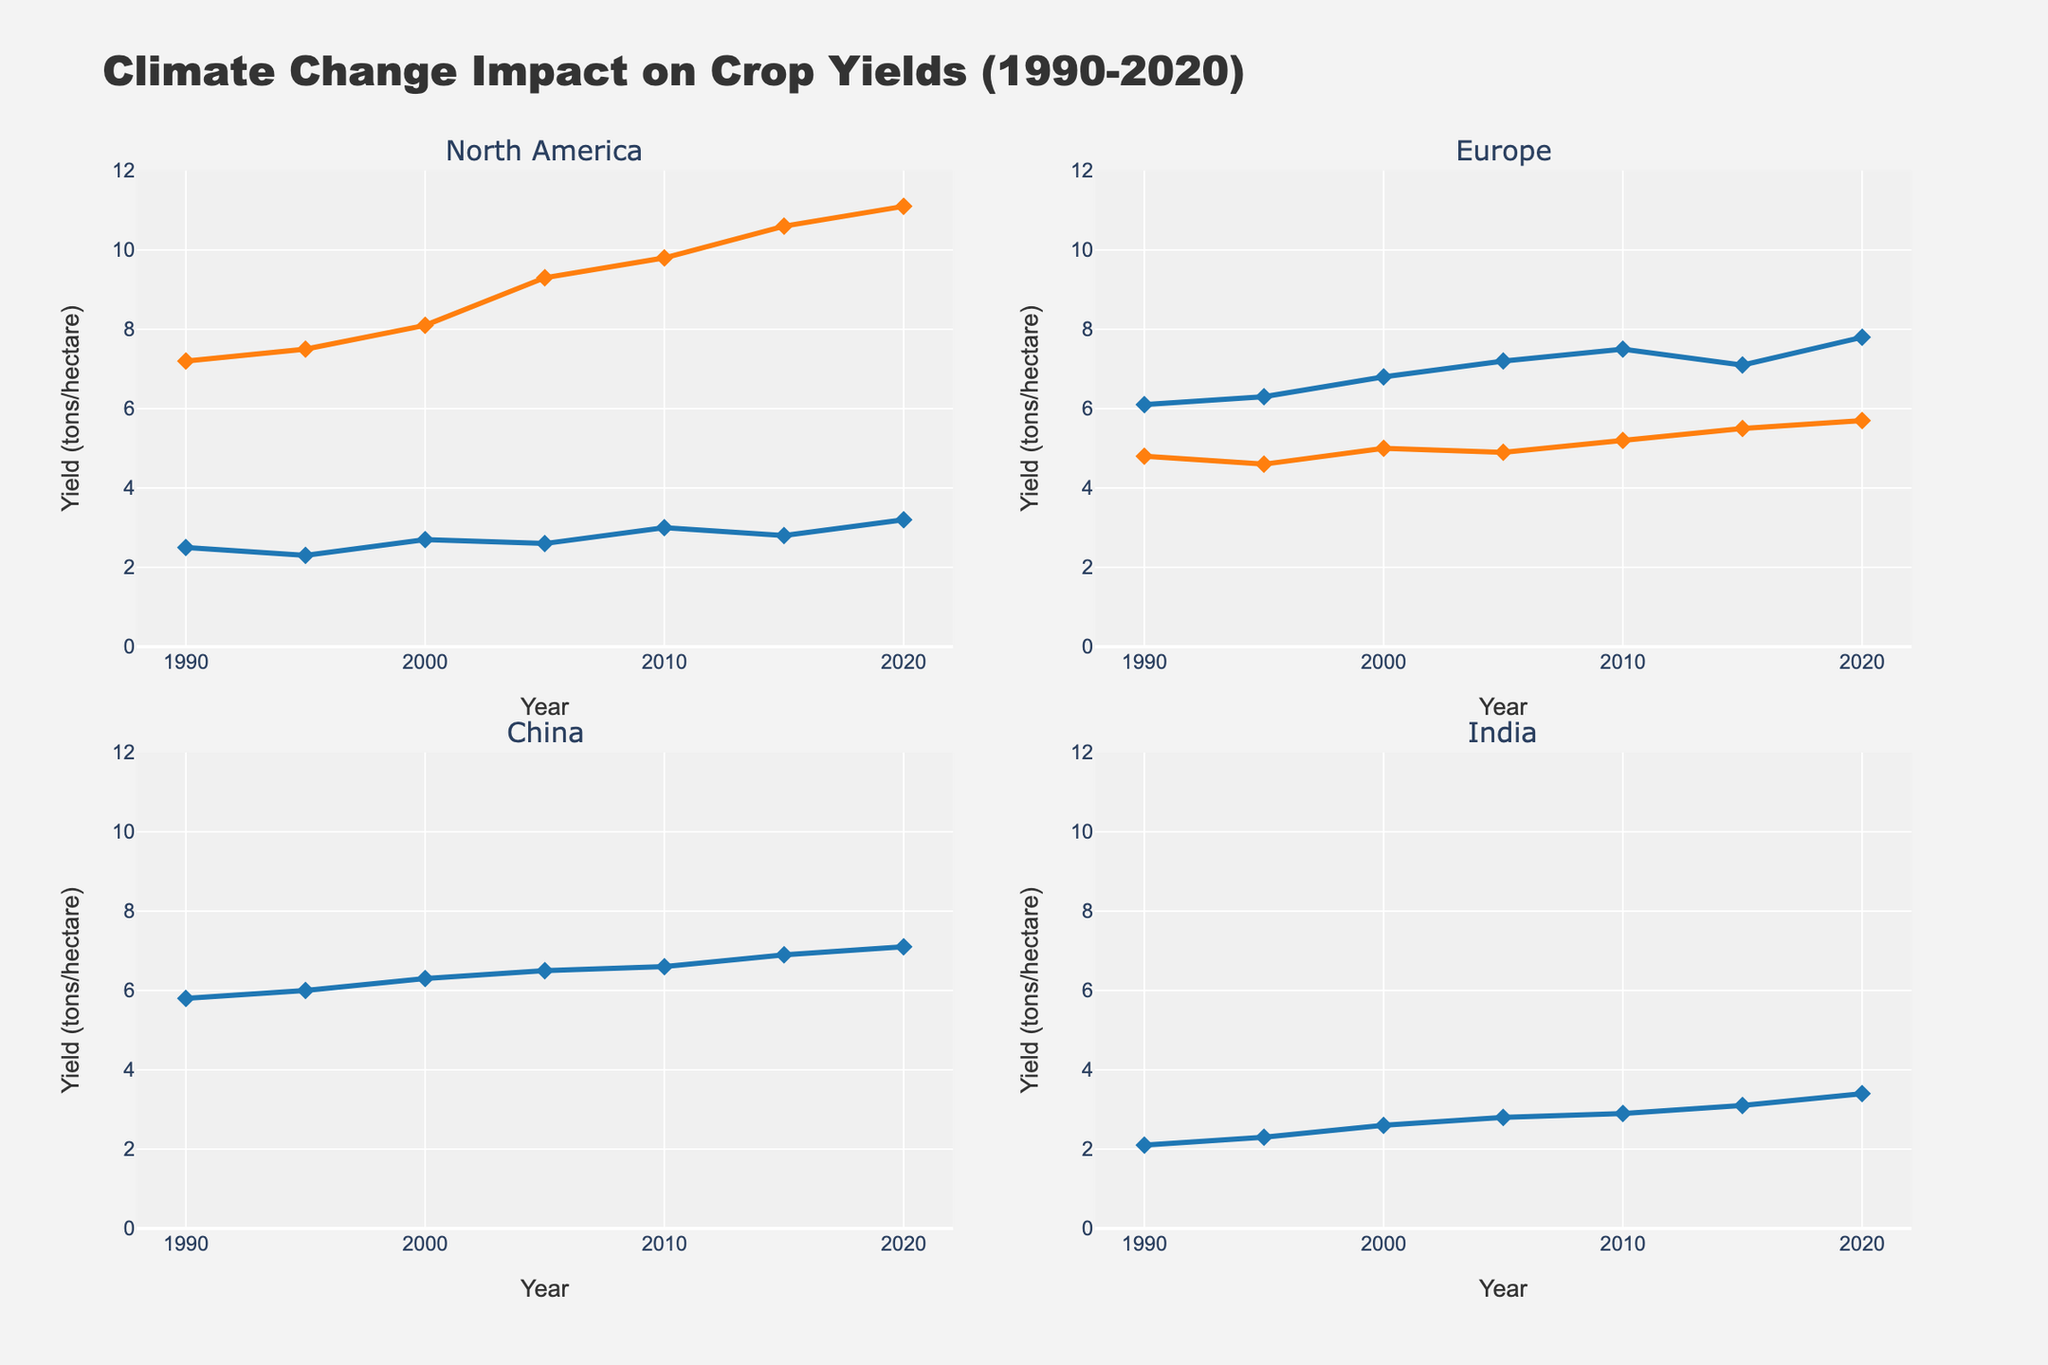What is the title of the figure? The title is located at the top center of the figure and is displayed clearly with larger font size.
Answer: Climate Change Impact on Crop Yields (1990-2020) What does the x-axis represent in the figure? The x-axis, which is the horizontal line on each subplot, is labeled "Year".
Answer: Year Why does the yield of North America Corn increase steadily from 1990 to 2020? By looking at the subplot for North America, it is evident that the yield of Corn increases steadily, which indicates improvement in agricultural practices or favorable climate conditions over these years.
Answer: Improvement in agriculture or favorable climate Which region shows the highest yield for Wheat in 2020? By examining each subplot, the yield of Wheat in each region can be observed. The subplot for Europe shows the highest Wheat yield in 2020.
Answer: Europe Between 1990 and 2020, which region shows the most significant increase in Corn yield? Comparing the subplots for North America and Europe (as they grow Corn), the increase in North America from 7.2 to 11.1 tons/hectare is larger compared to Europe’s increase from 6.1 to 7.8 tons/hectare.
Answer: North America Does China show a consistent trend in Rice yield from 1990 to 2020? Referring to the subplot for China, the yield for Rice shows a steady increase from 5.8 to 7.1 tons/hectare.
Answer: Yes Comparing India Wheat yield between 1990 and 2020, what is the overall change in yield? The subplot for India shows that Wheat yield increases from 2.1 tons/hectare in 1990 to 3.4 tons/hectare in 2020, which is a change of 1.3 tons/hectare.
Answer: 1.3 tons/hectare Which region exhibits the least variability in crop yields from 1990 to 2020? By observing all subplots, Europe shows the least variability in both Wheat and Corn yields as the lines are relatively smoother and closer together compared to other regions.
Answer: Europe In which year does North America experience the highest wheat yield, and what is the yield? Observing the North America subplot, the highest Wheat yield is in 2020, with a value of 3.2 tons/hectare.
Answer: 2020, 3.2 tons/hectare What are the crop yield trends in India for Rice and Wheat from 1990 to 2020? Refer to the subplot for India, where both Rice and Wheat show an upward trend in yields from 1990 to 2020. Rice increases from 2.7 to 3.9 tons/hectare, and Wheat from 2.1 to 3.4 tons/hectare.
Answer: Both increasing 